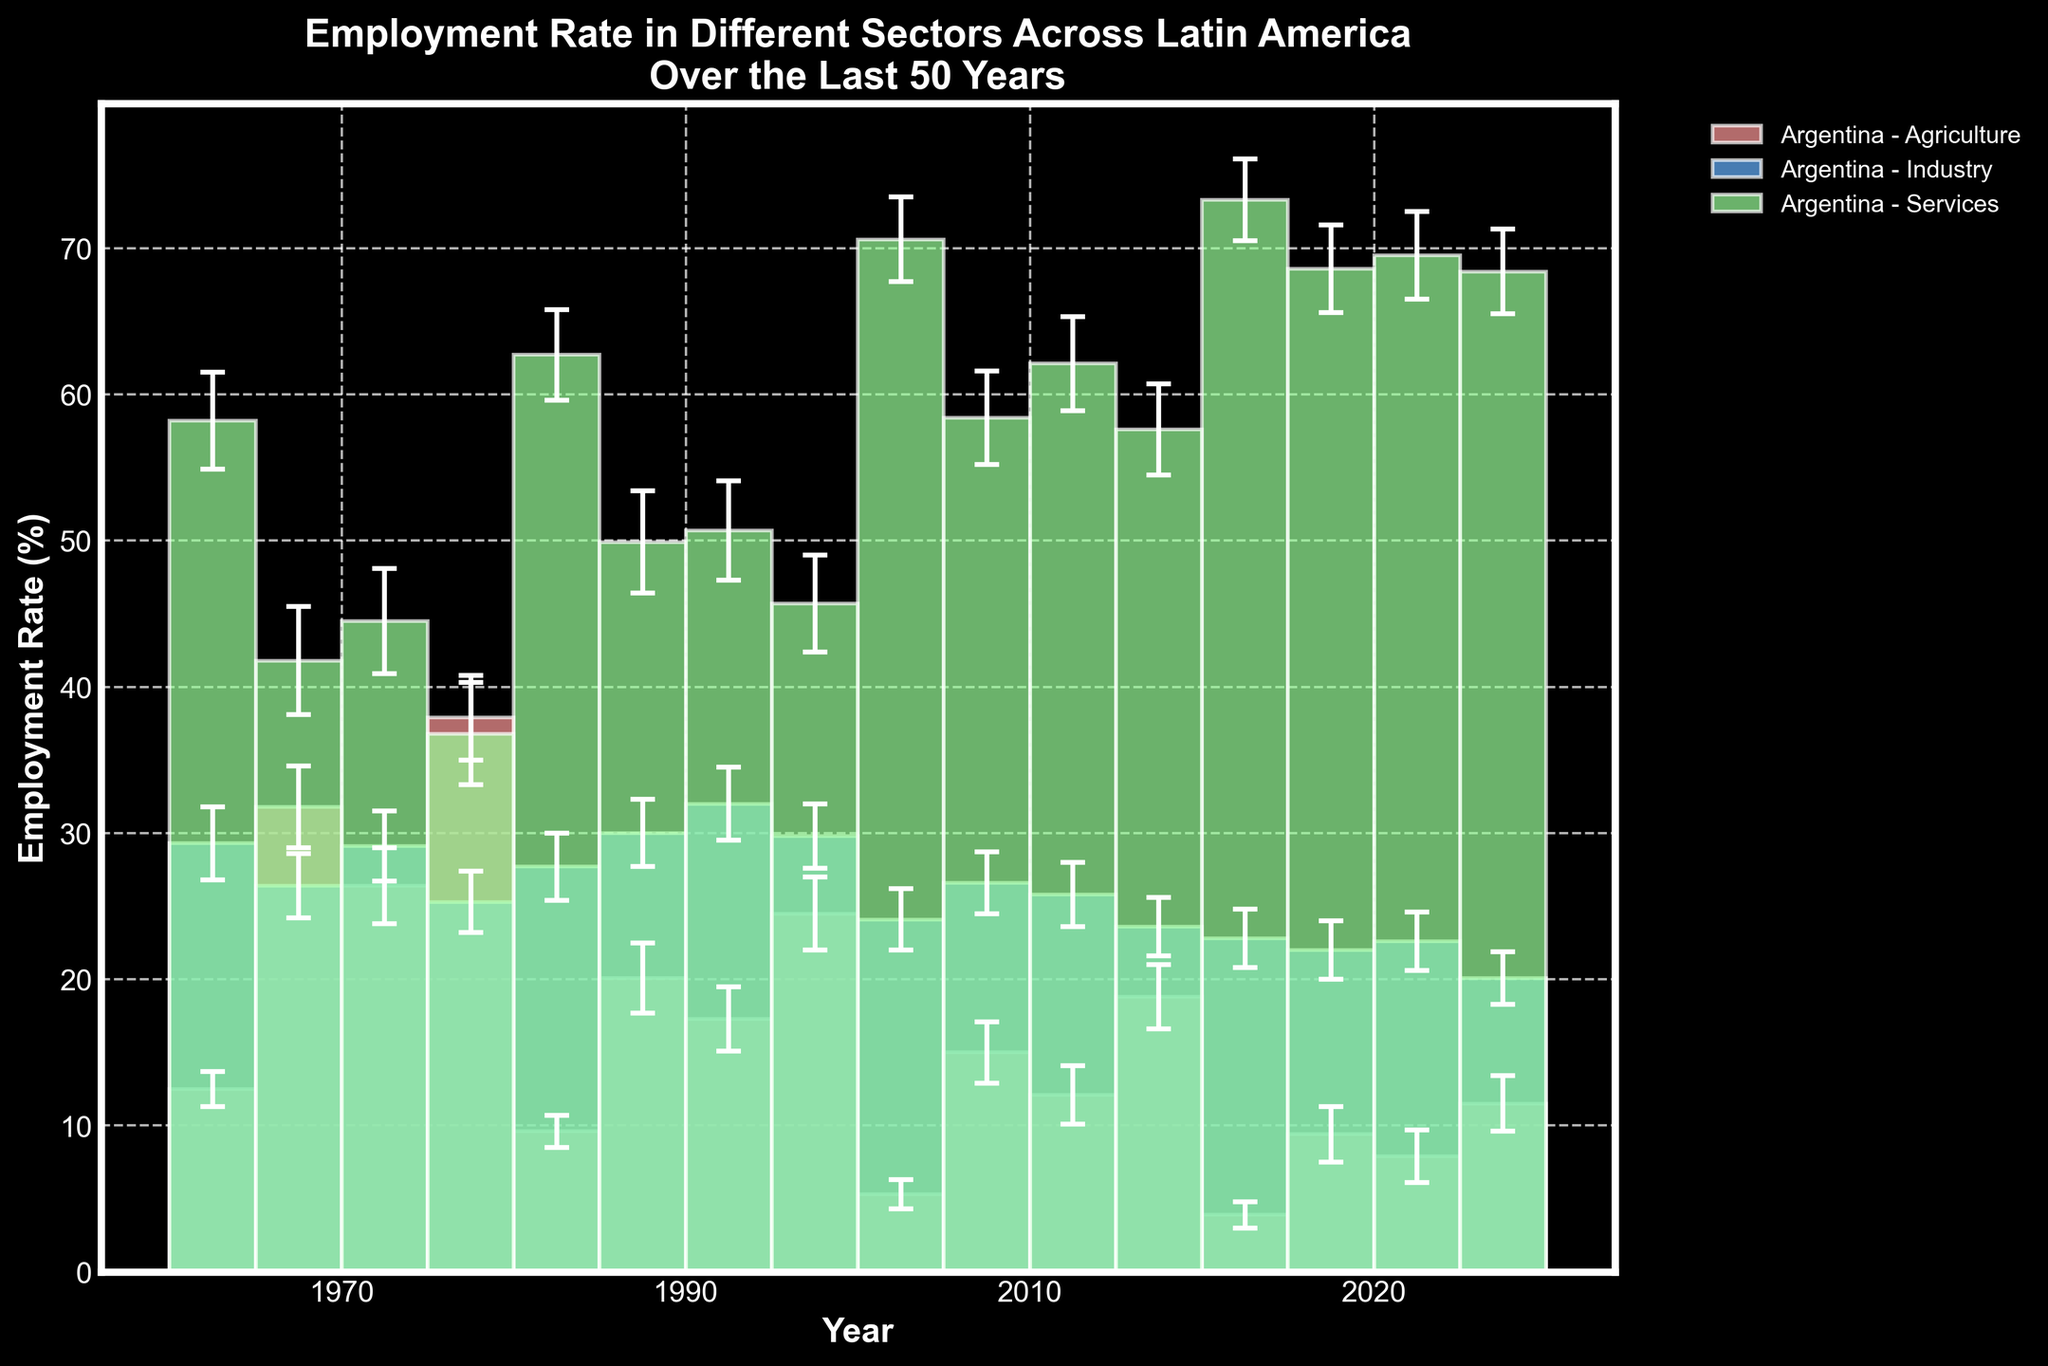What is the title of the figure? The title of the figure is displayed at the top and provides a high-level description of the content and focus of the plot. It aids in understanding what the plot represents at a glance.
Answer: Employment Rate in Different Sectors Across Latin America Over the Last 50 Years How are the employment rates of Argentina in different sectors represented? To identify Argentina's employment rates in different sectors, look for the specific bars labeled with "Argentina" in the legend and corresponding colors representing Agriculture, Industry, and Services.
Answer: Bars in different colors for Agriculture, Industry, and Services Which sector had the highest employment rate in Argentina in 2020? To determine the sector with the highest employment rate for Argentina in 2020, find the bar for Argentina in 2020 and compare the heights of the three bars (Agriculture, Industry, and Services).
Answer: Services By how much did the employment rate in Agriculture decrease from 1970 to 2020 in Brazil? Subtract the employment rate in Agriculture in Brazil for 2020 from the rate in 1970.
Answer: 31.8 - 9.4 = 22.4 Which country had the smallest employment rate in Industry in 2020? Locate the bars for the Industry sector for all countries in 2020 and identify the shortest bar.
Answer: Colombia Which sector shows the largest increase in employment rate in Colombia from 1970 to 2020? Compare the employment rates in Colombia for 1970 and 2020 across all three sectors (Agriculture, Industry, Services) and find the sector with the largest positive difference.
Answer: Services How does the error range of the Agriculture sector compare between Chile and Argentina in 1970? Find the error bars representing the Agriculture sector in 1970 for Chile and Argentina, and compare their lengths to see which one is larger.
Answer: Chile has a larger error range What is the general trend of the employment rate in the Services sector over the years for all countries? Examine the bars representing the Services sector across all years and countries and look for common patterns or trends, such as increasing or decreasing rates.
Answer: Increase Which country had the highest employment rate in Agriculture in the year 1990? Locate the bars for the Agriculture sector for all countries in 1990 and identify the highest bar.
Answer: Colombia Between 1970 and 2020, which country saw the largest drop in the employment rate in the Industry sector? Calculate the difference in the employment rate in the Industry sector between 1970 and 2020 for each country, then find the country with the largest drop.
Answer: Chile 